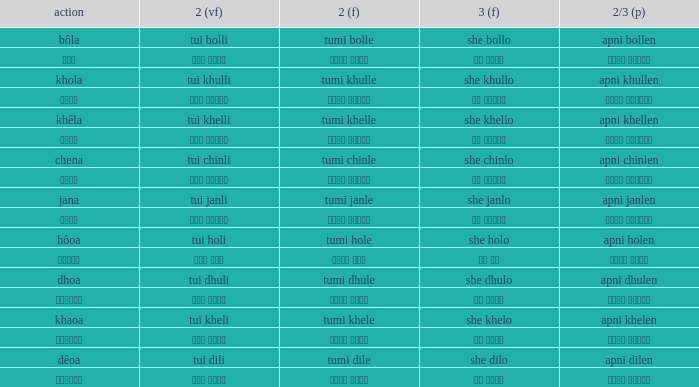What is the 2nd verb for Khola? Tumi khulle. 